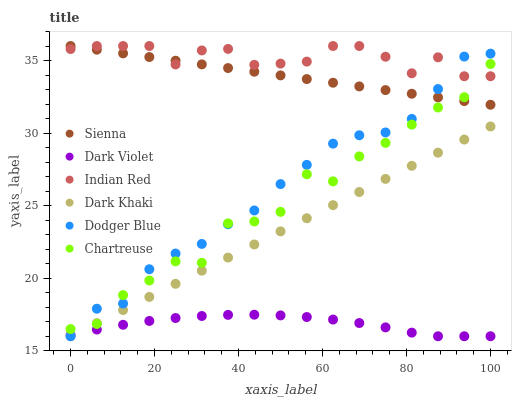Does Dark Violet have the minimum area under the curve?
Answer yes or no. Yes. Does Indian Red have the maximum area under the curve?
Answer yes or no. Yes. Does Sienna have the minimum area under the curve?
Answer yes or no. No. Does Sienna have the maximum area under the curve?
Answer yes or no. No. Is Sienna the smoothest?
Answer yes or no. Yes. Is Chartreuse the roughest?
Answer yes or no. Yes. Is Dark Violet the smoothest?
Answer yes or no. No. Is Dark Violet the roughest?
Answer yes or no. No. Does Dark Khaki have the lowest value?
Answer yes or no. Yes. Does Sienna have the lowest value?
Answer yes or no. No. Does Indian Red have the highest value?
Answer yes or no. Yes. Does Dark Violet have the highest value?
Answer yes or no. No. Is Dark Khaki less than Sienna?
Answer yes or no. Yes. Is Indian Red greater than Dark Khaki?
Answer yes or no. Yes. Does Dark Khaki intersect Chartreuse?
Answer yes or no. Yes. Is Dark Khaki less than Chartreuse?
Answer yes or no. No. Is Dark Khaki greater than Chartreuse?
Answer yes or no. No. Does Dark Khaki intersect Sienna?
Answer yes or no. No. 